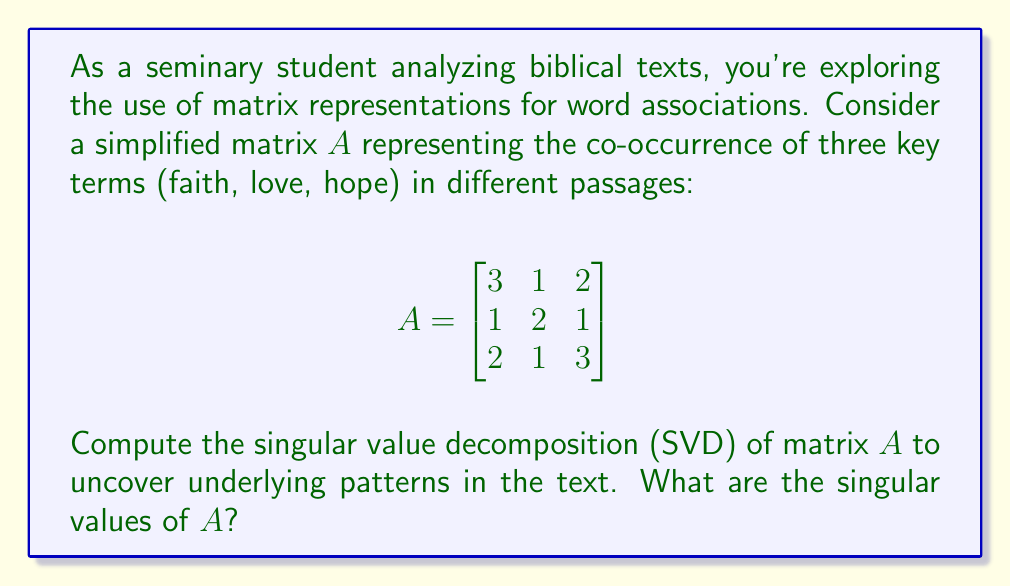Show me your answer to this math problem. To find the singular value decomposition of matrix $A$, we follow these steps:

1) First, calculate $A^TA$:
   $$A^TA = \begin{bmatrix}
   3 & 1 & 2 \\
   1 & 2 & 1 \\
   2 & 1 & 3
   \end{bmatrix}
   \begin{bmatrix}
   3 & 1 & 2 \\
   1 & 2 & 1 \\
   2 & 1 & 3
   \end{bmatrix}
   = \begin{bmatrix}
   14 & 8 & 13 \\
   8 & 6 & 7 \\
   13 & 7 & 14
   \end{bmatrix}$$

2) Find the eigenvalues of $A^TA$ by solving the characteristic equation:
   $\det(A^TA - \lambda I) = 0$
   
   This gives us the equation:
   $(\lambda - 32)(\lambda - 2)^2 = 0$

3) The eigenvalues are $\lambda_1 = 32$ and $\lambda_2 = \lambda_3 = 2$

4) The singular values are the square roots of these eigenvalues:
   $\sigma_1 = \sqrt{32} = 4\sqrt{2}$
   $\sigma_2 = \sigma_3 = \sqrt{2}$

Therefore, the singular values of $A$ are $4\sqrt{2}$, $\sqrt{2}$, and $\sqrt{2}$.
Answer: $4\sqrt{2}$, $\sqrt{2}$, $\sqrt{2}$ 